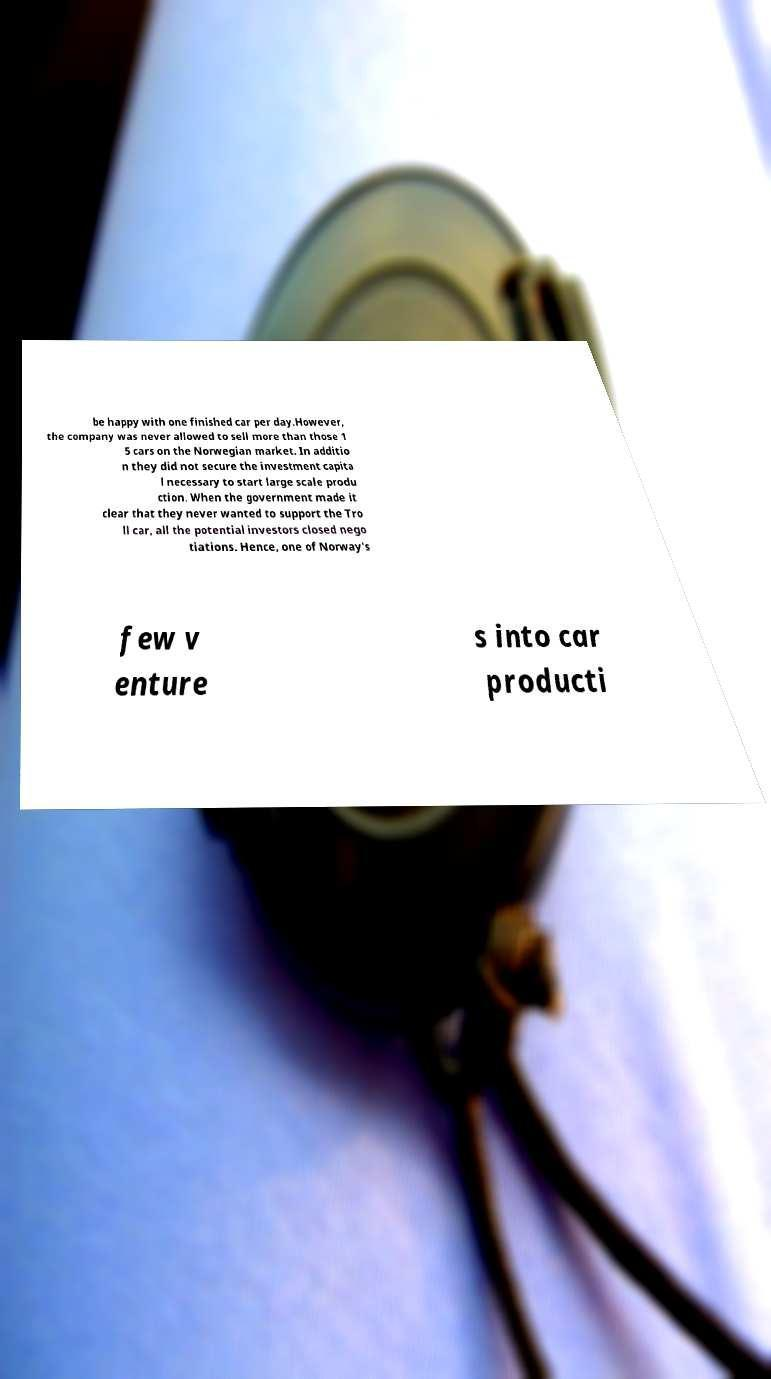There's text embedded in this image that I need extracted. Can you transcribe it verbatim? be happy with one finished car per day.However, the company was never allowed to sell more than those 1 5 cars on the Norwegian market. In additio n they did not secure the investment capita l necessary to start large scale produ ction. When the government made it clear that they never wanted to support the Tro ll car, all the potential investors closed nego tiations. Hence, one of Norway's few v enture s into car producti 